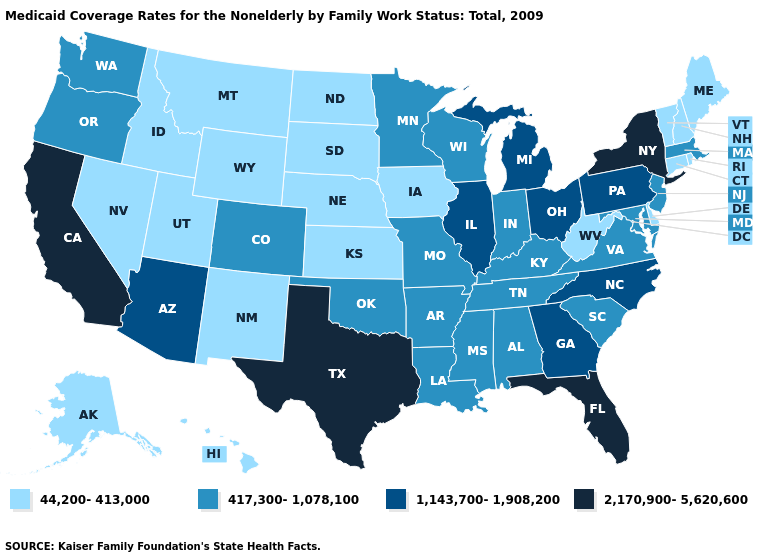Name the states that have a value in the range 44,200-413,000?
Give a very brief answer. Alaska, Connecticut, Delaware, Hawaii, Idaho, Iowa, Kansas, Maine, Montana, Nebraska, Nevada, New Hampshire, New Mexico, North Dakota, Rhode Island, South Dakota, Utah, Vermont, West Virginia, Wyoming. Name the states that have a value in the range 1,143,700-1,908,200?
Keep it brief. Arizona, Georgia, Illinois, Michigan, North Carolina, Ohio, Pennsylvania. Does Colorado have the lowest value in the West?
Quick response, please. No. What is the lowest value in states that border Wisconsin?
Keep it brief. 44,200-413,000. Name the states that have a value in the range 417,300-1,078,100?
Be succinct. Alabama, Arkansas, Colorado, Indiana, Kentucky, Louisiana, Maryland, Massachusetts, Minnesota, Mississippi, Missouri, New Jersey, Oklahoma, Oregon, South Carolina, Tennessee, Virginia, Washington, Wisconsin. What is the lowest value in states that border Oregon?
Quick response, please. 44,200-413,000. What is the lowest value in the MidWest?
Answer briefly. 44,200-413,000. Is the legend a continuous bar?
Answer briefly. No. What is the lowest value in the South?
Quick response, please. 44,200-413,000. Which states have the lowest value in the MidWest?
Give a very brief answer. Iowa, Kansas, Nebraska, North Dakota, South Dakota. Name the states that have a value in the range 417,300-1,078,100?
Give a very brief answer. Alabama, Arkansas, Colorado, Indiana, Kentucky, Louisiana, Maryland, Massachusetts, Minnesota, Mississippi, Missouri, New Jersey, Oklahoma, Oregon, South Carolina, Tennessee, Virginia, Washington, Wisconsin. What is the value of Kansas?
Give a very brief answer. 44,200-413,000. Name the states that have a value in the range 2,170,900-5,620,600?
Answer briefly. California, Florida, New York, Texas. What is the highest value in states that border California?
Give a very brief answer. 1,143,700-1,908,200. Name the states that have a value in the range 44,200-413,000?
Concise answer only. Alaska, Connecticut, Delaware, Hawaii, Idaho, Iowa, Kansas, Maine, Montana, Nebraska, Nevada, New Hampshire, New Mexico, North Dakota, Rhode Island, South Dakota, Utah, Vermont, West Virginia, Wyoming. 